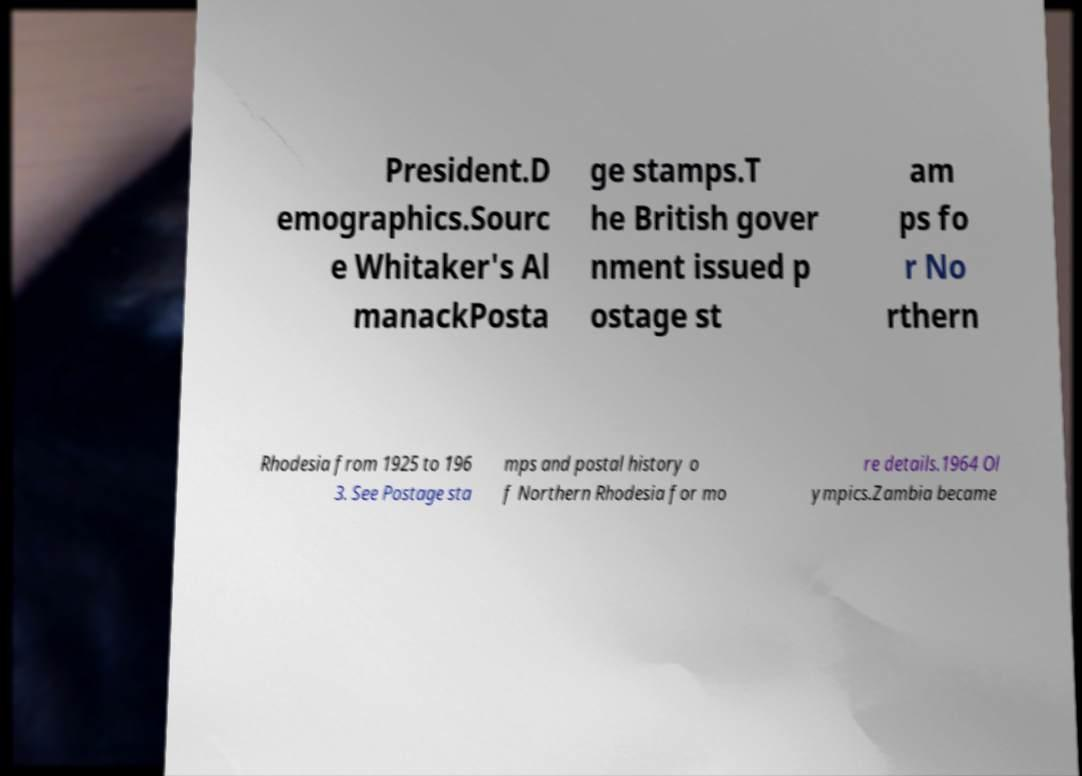There's text embedded in this image that I need extracted. Can you transcribe it verbatim? President.D emographics.Sourc e Whitaker's Al manackPosta ge stamps.T he British gover nment issued p ostage st am ps fo r No rthern Rhodesia from 1925 to 196 3. See Postage sta mps and postal history o f Northern Rhodesia for mo re details.1964 Ol ympics.Zambia became 